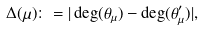Convert formula to latex. <formula><loc_0><loc_0><loc_500><loc_500>\Delta ( \mu ) \colon = | \deg ( \theta _ { \mu } ) - \deg ( \theta ^ { \prime } _ { \mu } ) | ,</formula> 